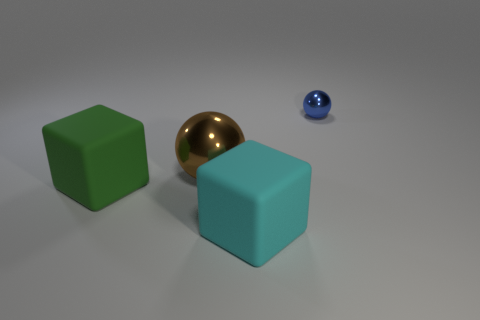Add 4 green things. How many objects exist? 8 Subtract 1 balls. How many balls are left? 1 Subtract all green cylinders. How many brown spheres are left? 1 Subtract all green blocks. How many blocks are left? 1 Subtract all small blue metal spheres. Subtract all big cyan cubes. How many objects are left? 2 Add 4 cyan rubber things. How many cyan rubber things are left? 5 Add 1 rubber cubes. How many rubber cubes exist? 3 Subtract 0 cyan spheres. How many objects are left? 4 Subtract all green balls. Subtract all purple cylinders. How many balls are left? 2 